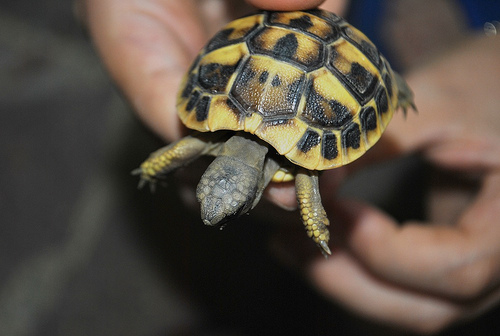<image>
Can you confirm if the turtle is next to the ground? No. The turtle is not positioned next to the ground. They are located in different areas of the scene. Is the turtle above the finger? Yes. The turtle is positioned above the finger in the vertical space, higher up in the scene. 